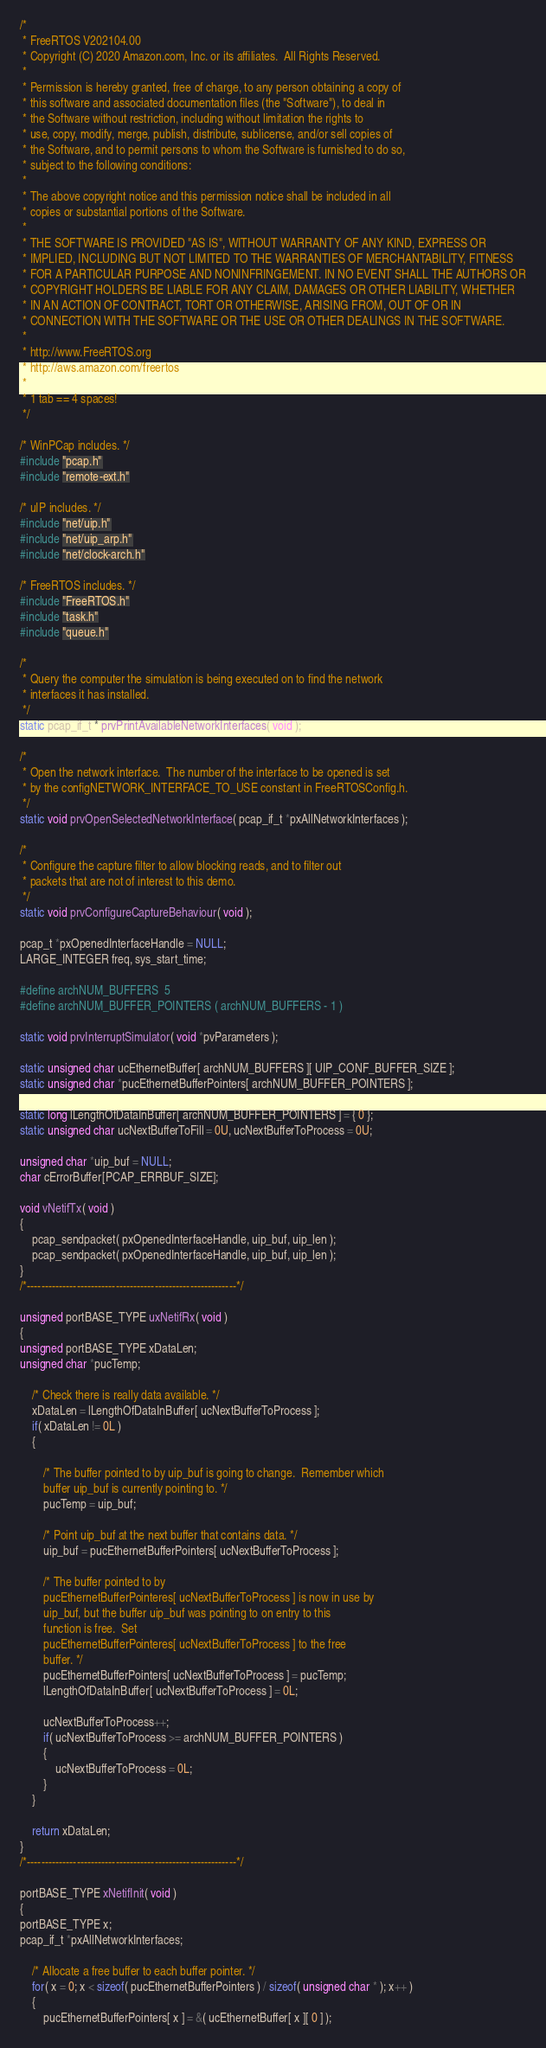Convert code to text. <code><loc_0><loc_0><loc_500><loc_500><_C_>/*
 * FreeRTOS V202104.00
 * Copyright (C) 2020 Amazon.com, Inc. or its affiliates.  All Rights Reserved.
 *
 * Permission is hereby granted, free of charge, to any person obtaining a copy of
 * this software and associated documentation files (the "Software"), to deal in
 * the Software without restriction, including without limitation the rights to
 * use, copy, modify, merge, publish, distribute, sublicense, and/or sell copies of
 * the Software, and to permit persons to whom the Software is furnished to do so,
 * subject to the following conditions:
 *
 * The above copyright notice and this permission notice shall be included in all
 * copies or substantial portions of the Software.
 *
 * THE SOFTWARE IS PROVIDED "AS IS", WITHOUT WARRANTY OF ANY KIND, EXPRESS OR
 * IMPLIED, INCLUDING BUT NOT LIMITED TO THE WARRANTIES OF MERCHANTABILITY, FITNESS
 * FOR A PARTICULAR PURPOSE AND NONINFRINGEMENT. IN NO EVENT SHALL THE AUTHORS OR
 * COPYRIGHT HOLDERS BE LIABLE FOR ANY CLAIM, DAMAGES OR OTHER LIABILITY, WHETHER
 * IN AN ACTION OF CONTRACT, TORT OR OTHERWISE, ARISING FROM, OUT OF OR IN
 * CONNECTION WITH THE SOFTWARE OR THE USE OR OTHER DEALINGS IN THE SOFTWARE.
 *
 * http://www.FreeRTOS.org
 * http://aws.amazon.com/freertos
 *
 * 1 tab == 4 spaces!
 */

/* WinPCap includes. */
#include "pcap.h"
#include "remote-ext.h"

/* uIP includes. */
#include "net/uip.h"
#include "net/uip_arp.h"
#include "net/clock-arch.h"

/* FreeRTOS includes. */
#include "FreeRTOS.h"
#include "task.h"
#include "queue.h"

/*
 * Query the computer the simulation is being executed on to find the network
 * interfaces it has installed.
 */
static pcap_if_t * prvPrintAvailableNetworkInterfaces( void );

/*
 * Open the network interface.  The number of the interface to be opened is set
 * by the configNETWORK_INTERFACE_TO_USE constant in FreeRTOSConfig.h.
 */
static void prvOpenSelectedNetworkInterface( pcap_if_t *pxAllNetworkInterfaces );

/*
 * Configure the capture filter to allow blocking reads, and to filter out
 * packets that are not of interest to this demo.
 */
static void prvConfigureCaptureBehaviour( void );

pcap_t *pxOpenedInterfaceHandle = NULL;
LARGE_INTEGER freq, sys_start_time;

#define archNUM_BUFFERS	5
#define archNUM_BUFFER_POINTERS ( archNUM_BUFFERS - 1 )

static void prvInterruptSimulator( void *pvParameters );

static unsigned char ucEthernetBuffer[ archNUM_BUFFERS ][ UIP_CONF_BUFFER_SIZE ];
static unsigned char *pucEthernetBufferPointers[ archNUM_BUFFER_POINTERS ];

static long lLengthOfDataInBuffer[ archNUM_BUFFER_POINTERS ] = { 0 };
static unsigned char ucNextBufferToFill = 0U, ucNextBufferToProcess = 0U;

unsigned char *uip_buf = NULL;
char cErrorBuffer[PCAP_ERRBUF_SIZE];

void vNetifTx( void )
{
	pcap_sendpacket( pxOpenedInterfaceHandle, uip_buf, uip_len );
	pcap_sendpacket( pxOpenedInterfaceHandle, uip_buf, uip_len );
}
/*-----------------------------------------------------------*/

unsigned portBASE_TYPE uxNetifRx( void )
{
unsigned portBASE_TYPE xDataLen;
unsigned char *pucTemp;

	/* Check there is really data available. */
	xDataLen = lLengthOfDataInBuffer[ ucNextBufferToProcess ];
	if( xDataLen != 0L )
	{

		/* The buffer pointed to by uip_buf is going to change.  Remember which
		buffer uip_buf is currently pointing to. */
		pucTemp = uip_buf;

		/* Point uip_buf at the next buffer that contains data. */
		uip_buf = pucEthernetBufferPointers[ ucNextBufferToProcess ];

		/* The buffer pointed to by 
		pucEthernetBufferPointeres[ ucNextBufferToProcess ] is now in use by
		uip_buf, but the buffer uip_buf was pointing to on entry to this
		function is free.  Set 
		pucEthernetBufferPointeres[ ucNextBufferToProcess ] to the free 
		buffer. */
		pucEthernetBufferPointers[ ucNextBufferToProcess ] = pucTemp;
		lLengthOfDataInBuffer[ ucNextBufferToProcess ] = 0L;

		ucNextBufferToProcess++;
		if( ucNextBufferToProcess >= archNUM_BUFFER_POINTERS )
		{
			ucNextBufferToProcess = 0L;
		}
	}

	return xDataLen;
}
/*-----------------------------------------------------------*/

portBASE_TYPE xNetifInit( void )
{
portBASE_TYPE x;
pcap_if_t *pxAllNetworkInterfaces;

	/* Allocate a free buffer to each buffer pointer. */
	for( x = 0; x < sizeof( pucEthernetBufferPointers ) / sizeof( unsigned char * ); x++ )
	{
		pucEthernetBufferPointers[ x ] = &( ucEthernetBuffer[ x ][ 0 ] );</code> 